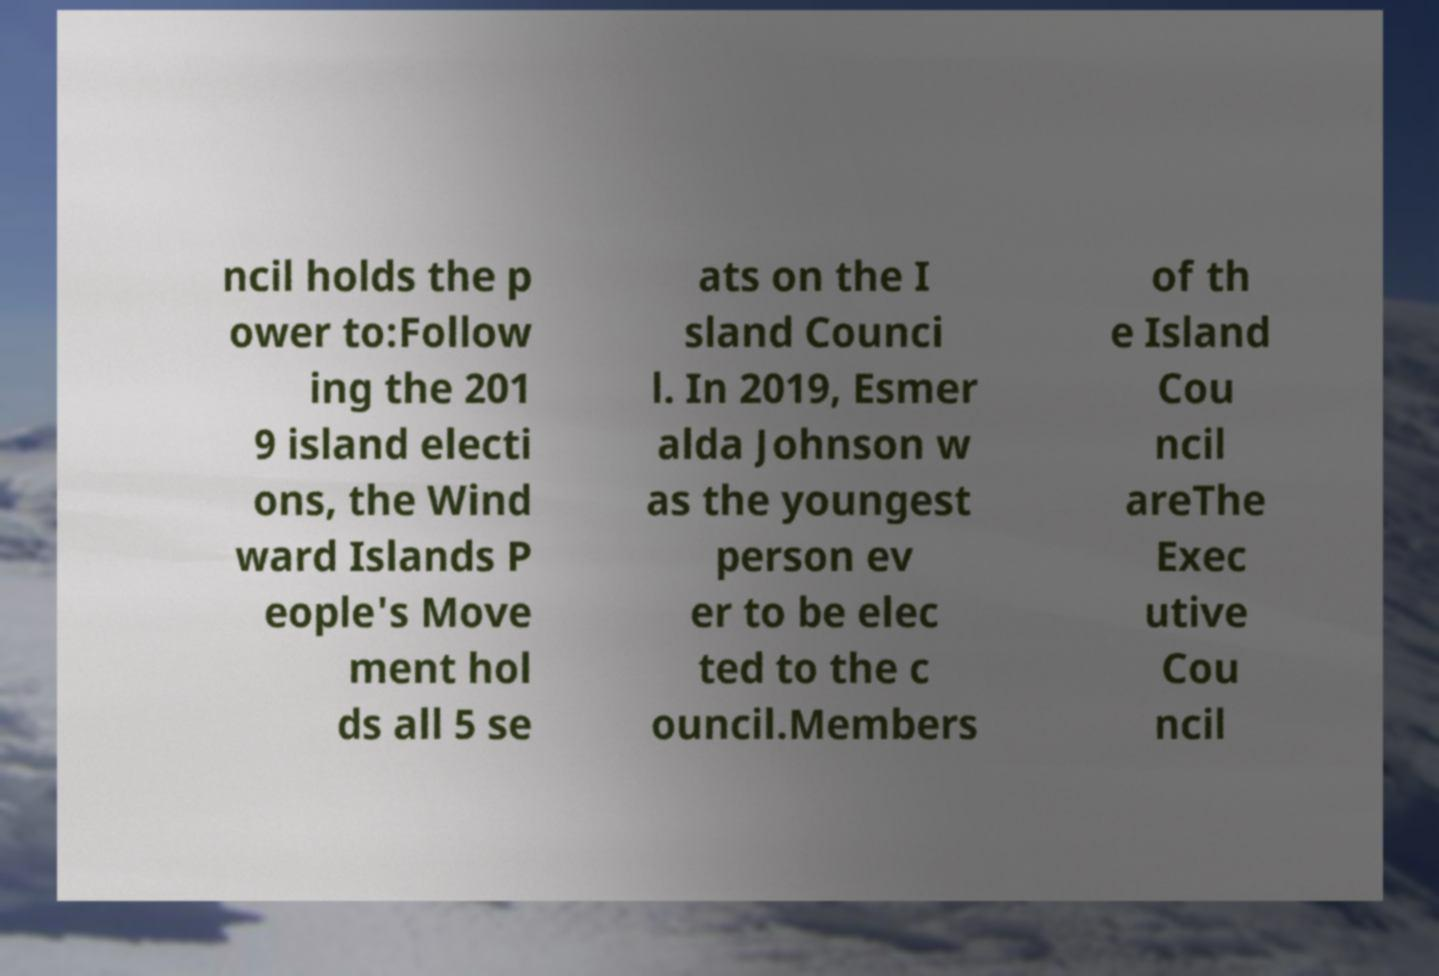There's text embedded in this image that I need extracted. Can you transcribe it verbatim? ncil holds the p ower to:Follow ing the 201 9 island electi ons, the Wind ward Islands P eople's Move ment hol ds all 5 se ats on the I sland Counci l. In 2019, Esmer alda Johnson w as the youngest person ev er to be elec ted to the c ouncil.Members of th e Island Cou ncil areThe Exec utive Cou ncil 